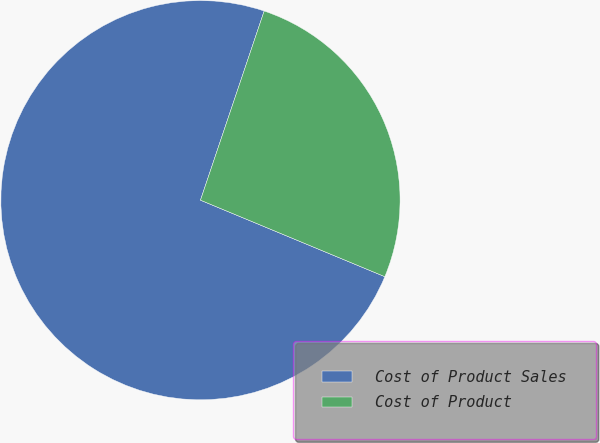<chart> <loc_0><loc_0><loc_500><loc_500><pie_chart><fcel>Cost of Product Sales<fcel>Cost of Product<nl><fcel>73.91%<fcel>26.09%<nl></chart> 